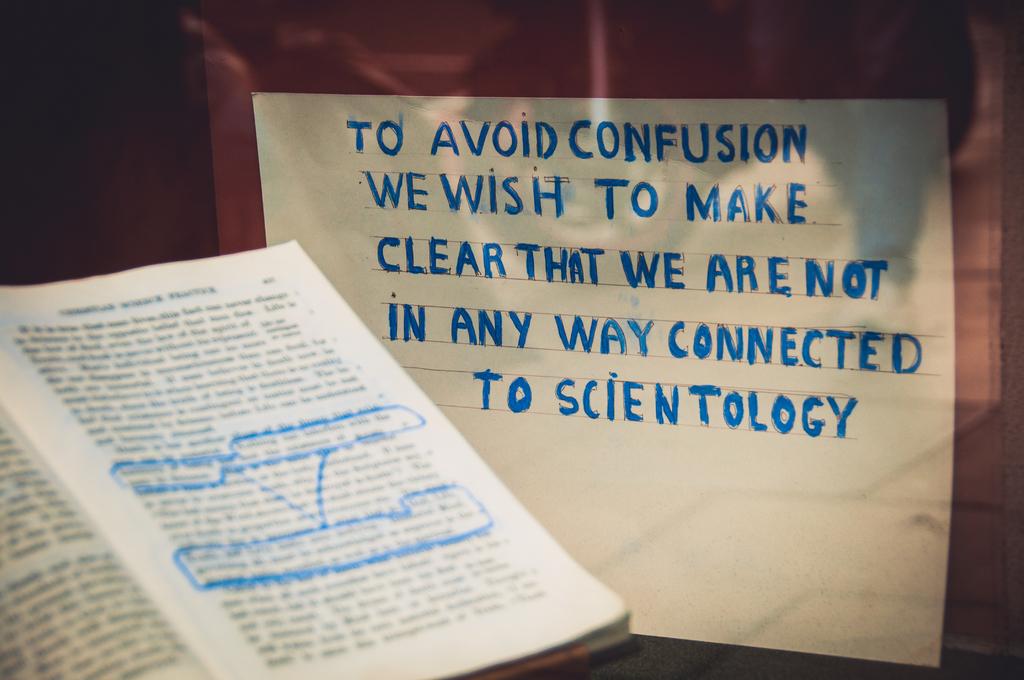What are they not connected to>?
Give a very brief answer. Scientology. What religion is this quote about?
Provide a succinct answer. Scientology. 